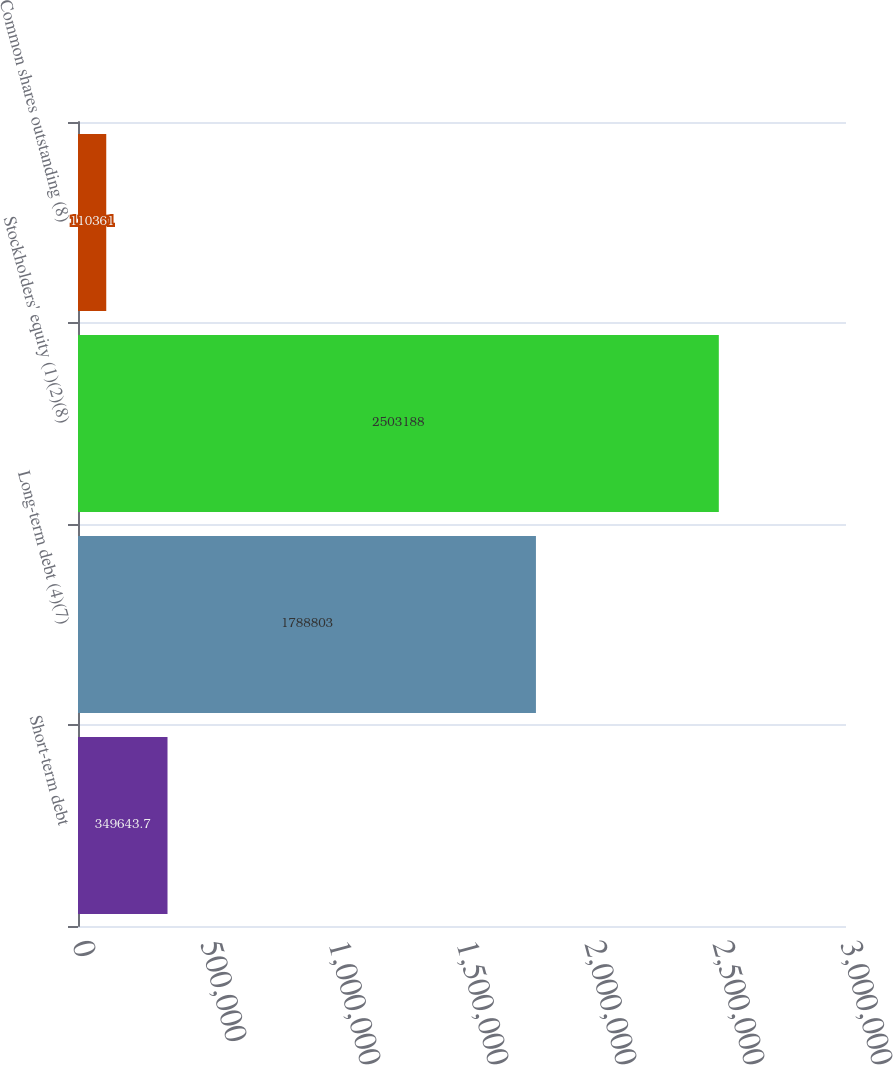<chart> <loc_0><loc_0><loc_500><loc_500><bar_chart><fcel>Short-term debt<fcel>Long-term debt (4)(7)<fcel>Stockholders' equity (1)(2)(8)<fcel>Common shares outstanding (8)<nl><fcel>349644<fcel>1.7888e+06<fcel>2.50319e+06<fcel>110361<nl></chart> 